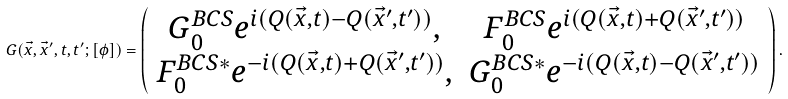<formula> <loc_0><loc_0><loc_500><loc_500>G ( \vec { x } , \vec { x } ^ { \prime } , t , t ^ { \prime } ; [ \phi ] ) = \left ( \begin{array} { c c } G _ { 0 } ^ { B C S } e ^ { i ( Q ( \vec { x } , t ) - Q ( \vec { x } ^ { \prime } , t ^ { \prime } ) ) } , & F _ { 0 } ^ { B C S } e ^ { i ( Q ( \vec { x } , t ) + Q ( \vec { x } ^ { \prime } , t ^ { \prime } ) ) } \\ F _ { 0 } ^ { B C S * } e ^ { - i ( Q ( \vec { x } , t ) + Q ( \vec { x } ^ { \prime } , t ^ { \prime } ) ) } , & G _ { 0 } ^ { B C S * } e ^ { - i ( Q ( \vec { x } , t ) - Q ( \vec { x } ^ { \prime } , t ^ { \prime } ) ) } \end{array} \right ) .</formula> 